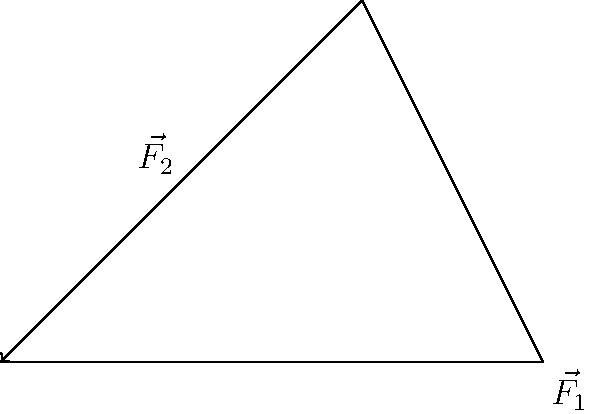When repositioning a patient in bed, two nurses apply forces $\vec{F_1}$ and $\vec{F_2}$ as shown in the diagram. $\vec{F_1}$ is 3 N horizontally to the right, and $\vec{F_2}$ is 2 N at an angle of 45° above the horizontal. Calculate the magnitude of the resultant force $\vec{R}$ to the nearest 0.1 N. To find the resultant force, we need to add the two force vectors using the parallelogram method:

1. Break down $\vec{F_2}$ into its horizontal and vertical components:
   $F_{2x} = 2 \cos 45° = 2 \times \frac{\sqrt{2}}{2} = \sqrt{2}$ N
   $F_{2y} = 2 \sin 45° = 2 \times \frac{\sqrt{2}}{2} = \sqrt{2}$ N

2. Add the horizontal components:
   $R_x = F_{1x} + F_{2x} = 3 + \sqrt{2}$ N

3. The vertical component is just $F_{2y}$:
   $R_y = F_{2y} = \sqrt{2}$ N

4. Calculate the magnitude of the resultant force using the Pythagorean theorem:
   $|\vec{R}| = \sqrt{R_x^2 + R_y^2} = \sqrt{(3 + \sqrt{2})^2 + (\sqrt{2})^2}$

5. Simplify:
   $|\vec{R}| = \sqrt{9 + 6\sqrt{2} + 2 + 2} = \sqrt{11 + 6\sqrt{2}}$

6. Calculate the numerical value:
   $|\vec{R}| \approx 4.65$ N

7. Round to the nearest 0.1 N:
   $|\vec{R}| \approx 4.7$ N
Answer: 4.7 N 